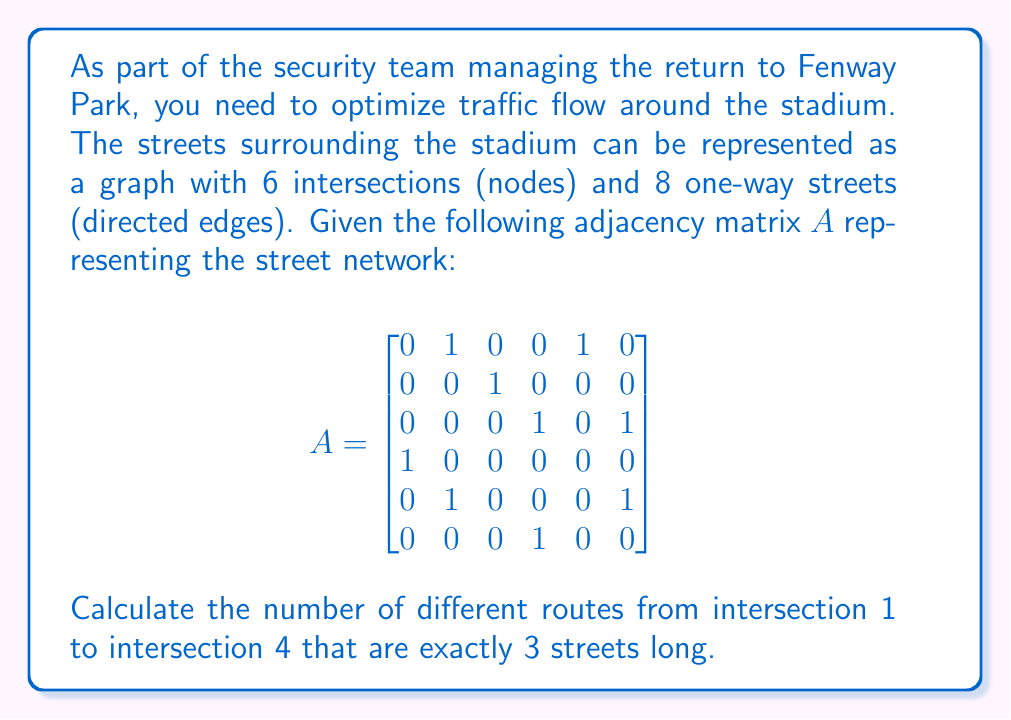Teach me how to tackle this problem. To solve this problem, we'll use the properties of adjacency matrices in graph theory. The key insight is that the element $(i,j)$ in the matrix $A^n$ represents the number of paths of length $n$ from node $i$ to node $j$.

Steps to solve:

1) We need to calculate $A^3$ since we're looking for routes that are exactly 3 streets long.

2) To calculate $A^3$, we'll multiply $A$ by itself twice:

   $A^2 = A \cdot A$
   $A^3 = A^2 \cdot A$

3) Let's calculate $A^2$ first:

   $$A^2 = \begin{bmatrix}
   0 & 1 & 1 & 0 & 0 & 1 \\
   0 & 0 & 0 & 1 & 0 & 1 \\
   1 & 0 & 0 & 0 & 0 & 0 \\
   0 & 1 & 0 & 0 & 1 & 0 \\
   0 & 1 & 1 & 0 & 0 & 0 \\
   1 & 0 & 0 & 0 & 0 & 0
   \end{bmatrix}$$

4) Now let's calculate $A^3 = A^2 \cdot A$:

   $$A^3 = \begin{bmatrix}
   0 & 1 & 0 & 2 & 0 & 1 \\
   1 & 0 & 0 & 0 & 0 & 0 \\
   0 & 1 & 0 & 0 & 1 & 0 \\
   0 & 1 & 1 & 0 & 0 & 1 \\
   0 & 1 & 1 & 1 & 0 & 1 \\
   0 & 1 & 0 & 0 & 1 & 0
   \end{bmatrix}$$

5) The number of routes from intersection 1 to intersection 4 that are exactly 3 streets long is given by the element in the first row, fourth column of $A^3$.
Answer: The number of different routes from intersection 1 to intersection 4 that are exactly 3 streets long is 2. 